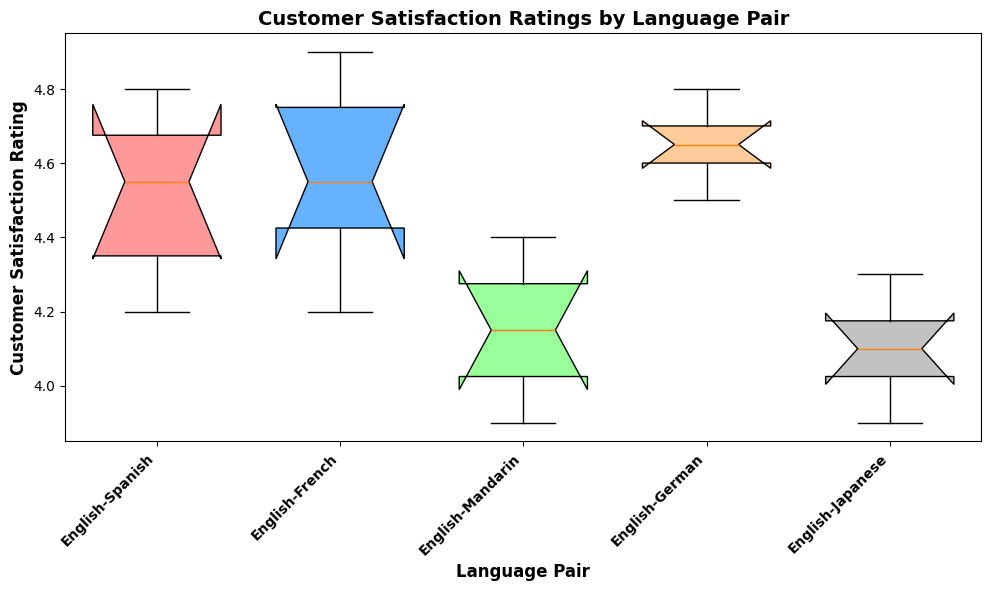What is the median customer satisfaction rating for the English-Spanish language pair? The median is the middle value in a sorted list. For English-Spanish ratings (4.2, 4.3, 4.5, 4.6, 4.7, 4.8), the median is the average of the two middle values: (4.5 + 4.6)/2 = 4.55.
Answer: 4.55 Which language pair has the highest median customer satisfaction rating? To find the highest median, compare the median values of each language pair. English-French and English-German both have medians of 4.6 and 4.7 respectively, making English-German the highest.
Answer: English-German What is the range of customer satisfaction ratings for the English-Japanese language pair? The range is the difference between the highest and lowest values. For English-Japanese, the highest rating is 4.3 and the lowest is 3.9. The range is 4.3 - 3.9 = 0.4.
Answer: 0.4 Which language pair has the largest interquartile range (IQR)? The IQR is the difference between the 75th percentile (Q3) and the 25th percentile (Q1). By examining the box sizes, English-Mandarin has the widest box, indicating the largest IQR.
Answer: English-Mandarin Does any language pair have outliers? Outliers are data points that fall outside the whiskers of the box plot. By inspecting the plot, no language pair shows data points significantly outside the whiskers.
Answer: No Are there any language pairs with no variation in customer satisfaction ratings? To find this, look for language pairs where the whiskers, box, and median are all the same value. All language pairs show some variation in the ratings.
Answer: No Which two language pairs have the most similar customer satisfaction rating distributions? By comparing the sizes and positions of the boxes and whiskers, English-Spanish and English-French have very similar distributions with overlapping ranges and similar medians.
Answer: English-Spanish and English-French What is the difference between the median ratings of English-French and English-Japanese? The median for English-French is around 4.6, for English-Japanese is around 4.1. The difference is 4.6 - 4.1 = 0.5.
Answer: 0.5 What color is associated with the box plot for the English-German language pair? By observing the colors assigned to each box plot, the English-German box plot is the fourth one and is colored orange.
Answer: Orange 